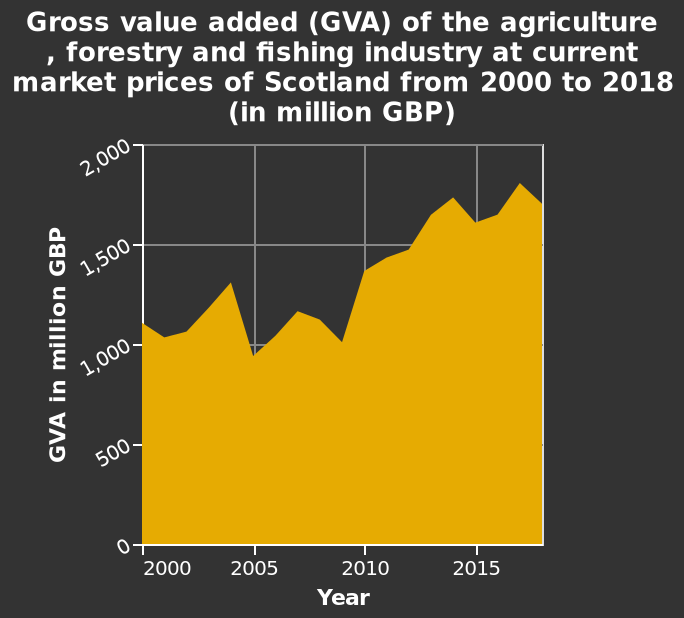<image>
What is the time period covered by the data represented in the graph? The data in the graph spans from the year 2000 to 2018. What does the x-axis represent in the area chart? The x-axis represents the years from 2000 to 2018. Has the GVA of the agriculture, forestry, and fishing industry in Scotland decreased or increased between 2000 and 2018? It has increased. What time period is considered in the increase of GVA for the agriculture, forestry, and fishing industry in Scotland? 2000 to 2018. What is the unit of measurement for the y-axis on the graph?  The unit of measurement for the y-axis on the graph is million GBP. Is the unit of measurement for the y-axis on the graph billion GBP? No. The unit of measurement for the y-axis on the graph is million GBP. 